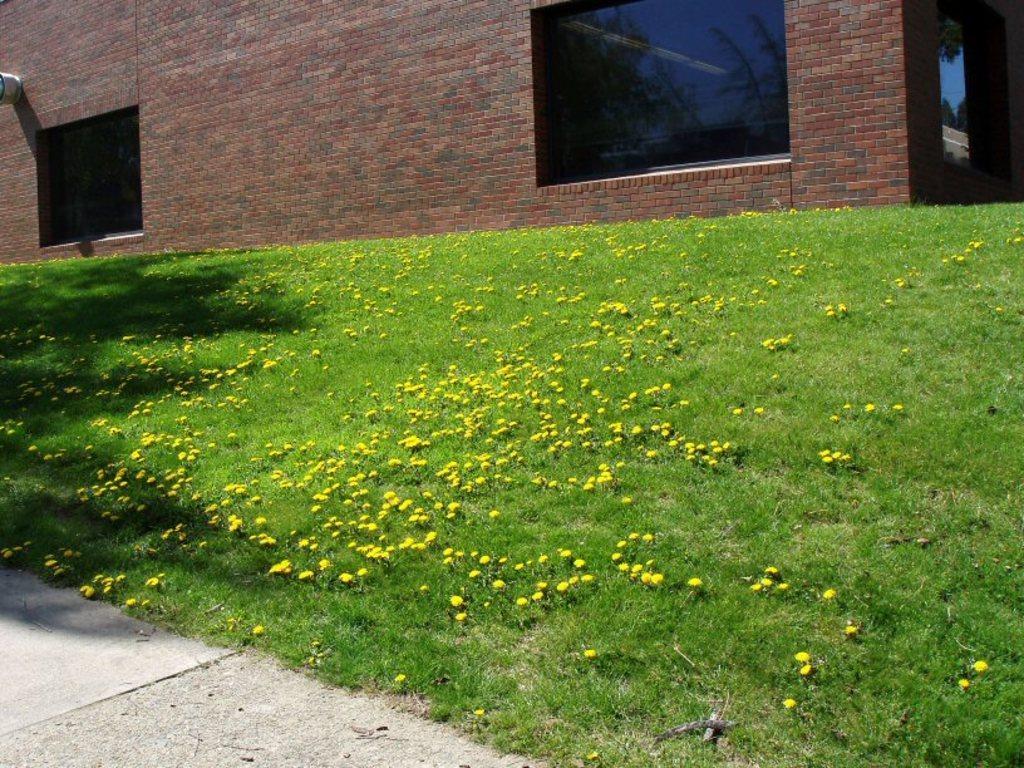In one or two sentences, can you explain what this image depicts? In this image there are plants having flowers. There are plants on the grassland. Background there is a wall having windows. Left bottom there is a path. 